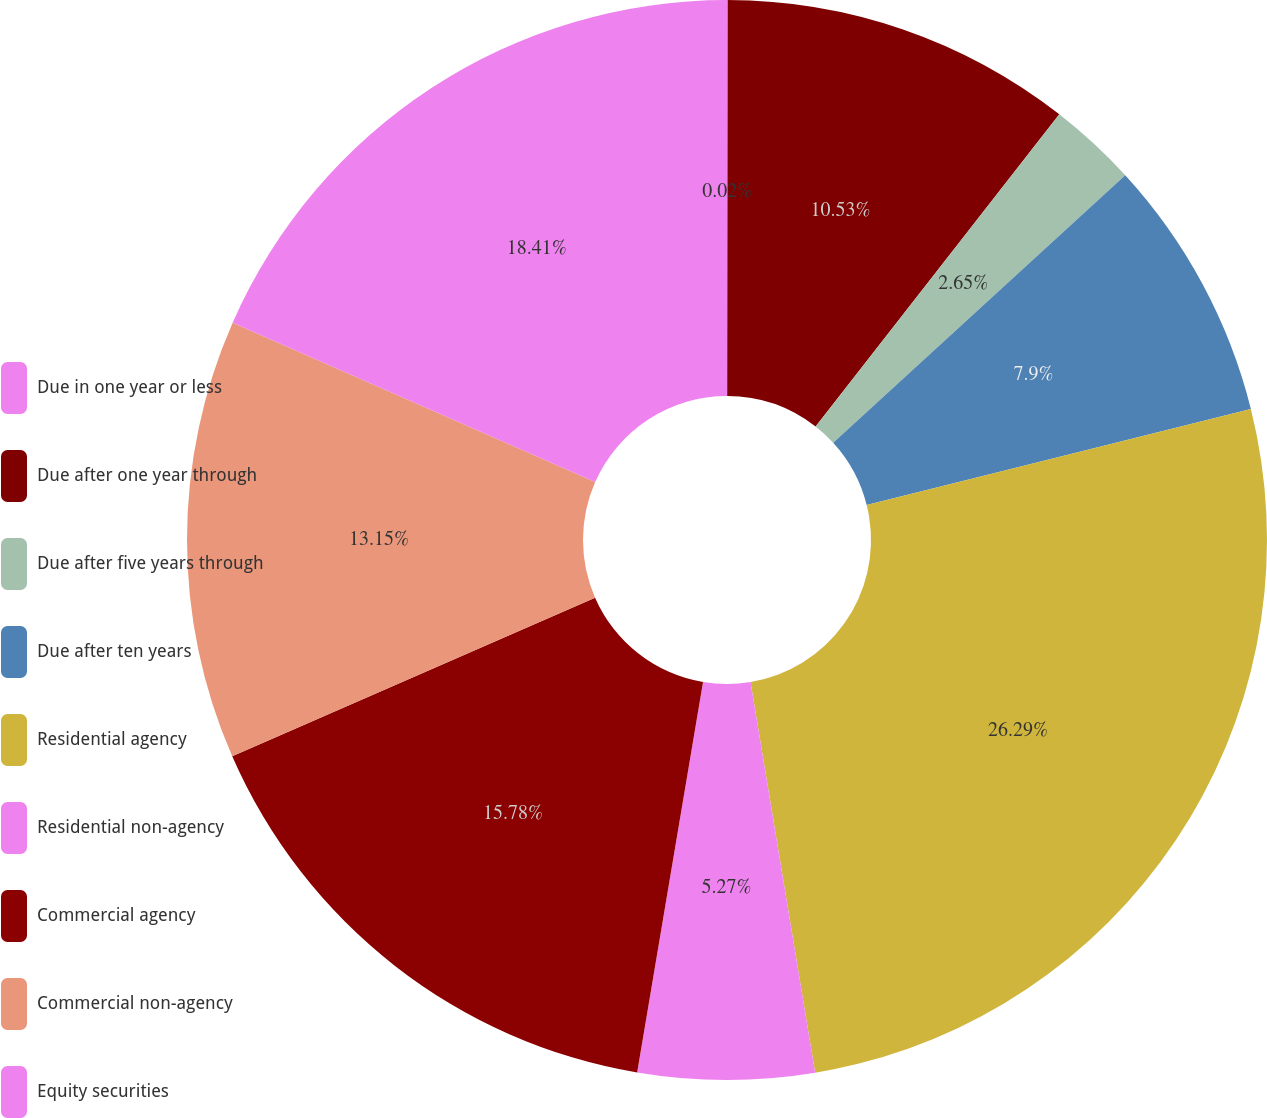Convert chart. <chart><loc_0><loc_0><loc_500><loc_500><pie_chart><fcel>Due in one year or less<fcel>Due after one year through<fcel>Due after five years through<fcel>Due after ten years<fcel>Residential agency<fcel>Residential non-agency<fcel>Commercial agency<fcel>Commercial non-agency<fcel>Equity securities<nl><fcel>0.02%<fcel>10.53%<fcel>2.65%<fcel>7.9%<fcel>26.29%<fcel>5.27%<fcel>15.78%<fcel>13.15%<fcel>18.41%<nl></chart> 